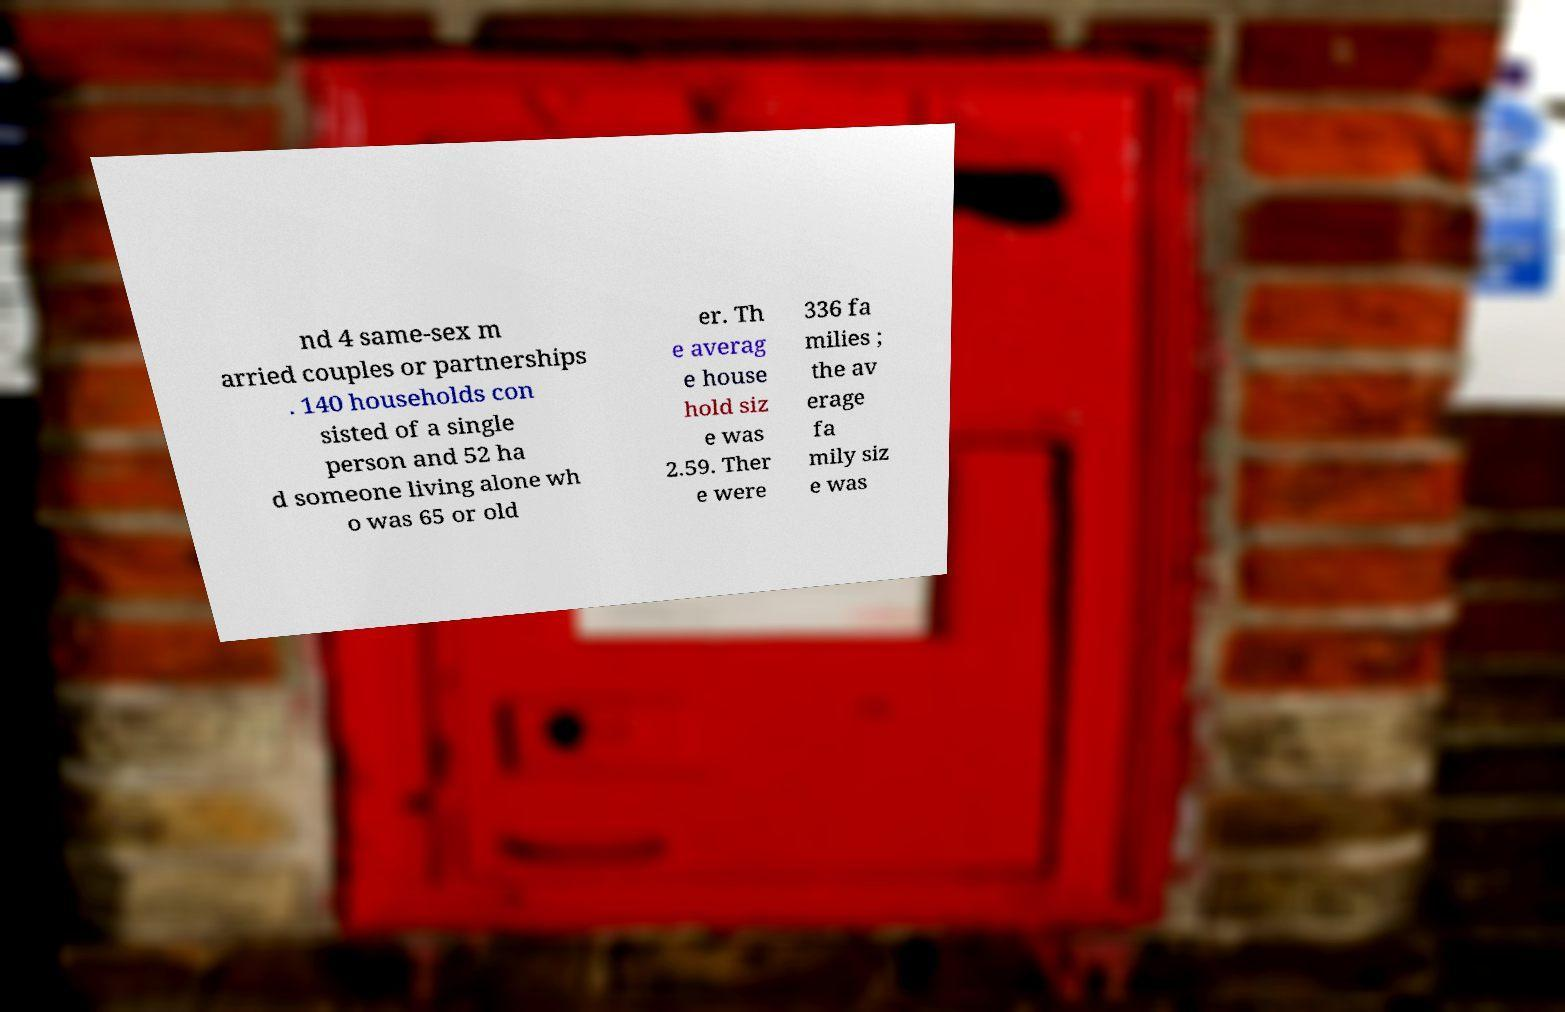Can you read and provide the text displayed in the image?This photo seems to have some interesting text. Can you extract and type it out for me? nd 4 same-sex m arried couples or partnerships . 140 households con sisted of a single person and 52 ha d someone living alone wh o was 65 or old er. Th e averag e house hold siz e was 2.59. Ther e were 336 fa milies ; the av erage fa mily siz e was 